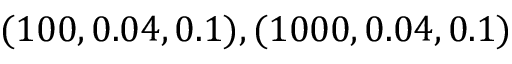<formula> <loc_0><loc_0><loc_500><loc_500>( 1 0 0 , 0 . 0 4 , 0 . 1 ) , ( 1 0 0 0 , 0 . 0 4 , 0 . 1 )</formula> 